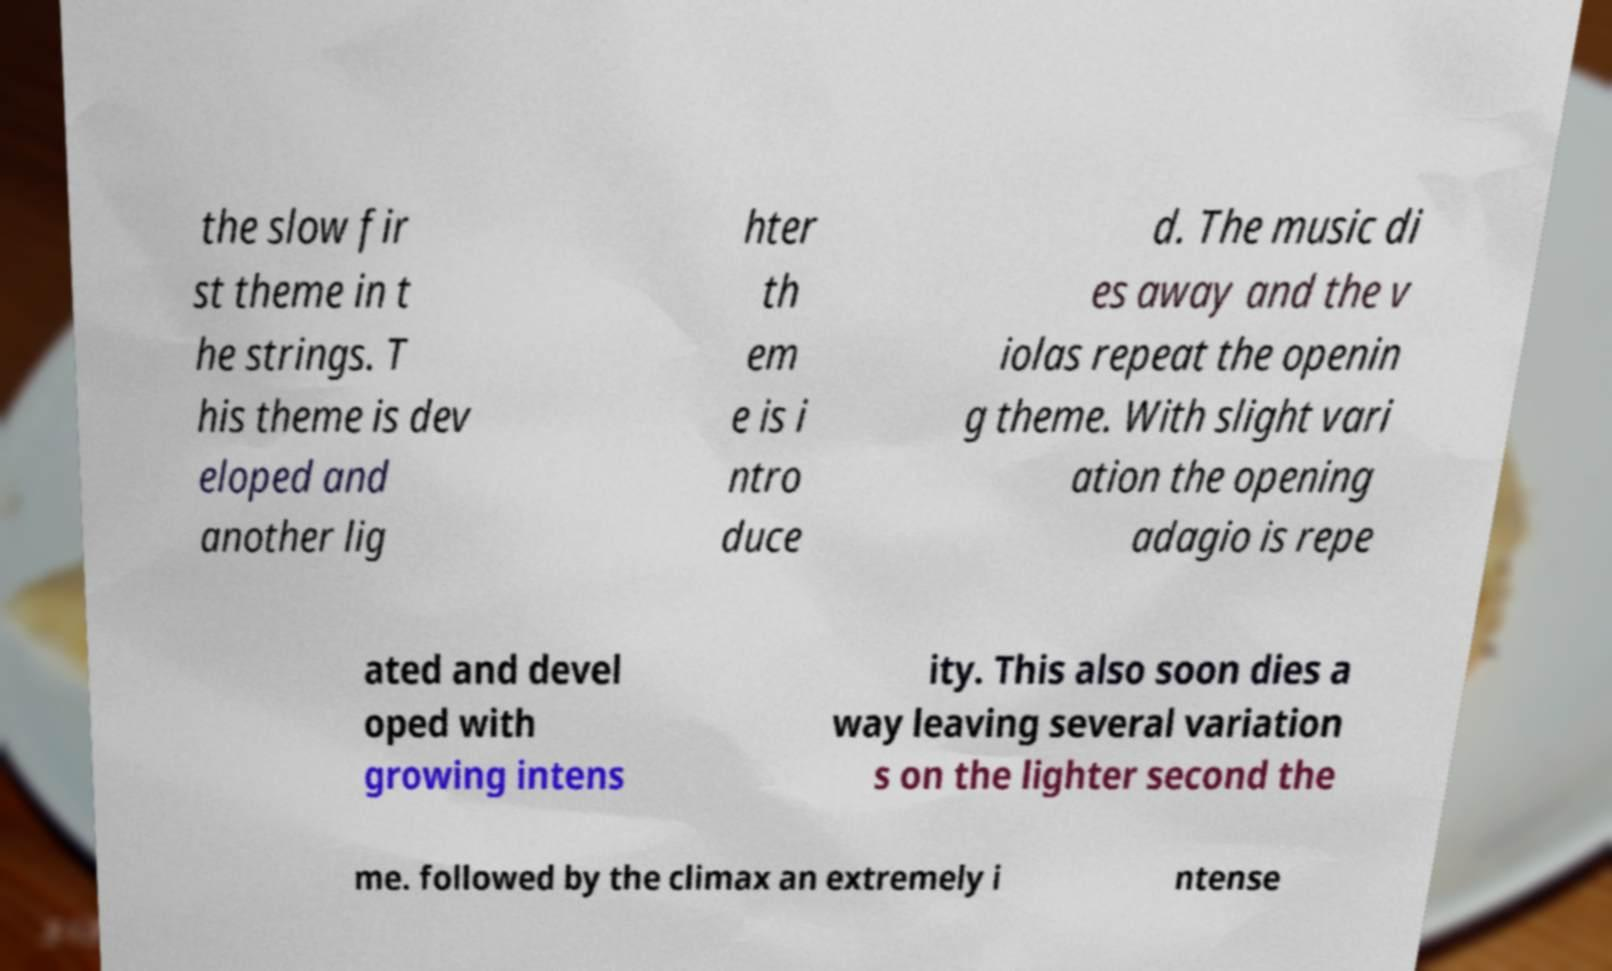For documentation purposes, I need the text within this image transcribed. Could you provide that? the slow fir st theme in t he strings. T his theme is dev eloped and another lig hter th em e is i ntro duce d. The music di es away and the v iolas repeat the openin g theme. With slight vari ation the opening adagio is repe ated and devel oped with growing intens ity. This also soon dies a way leaving several variation s on the lighter second the me. followed by the climax an extremely i ntense 